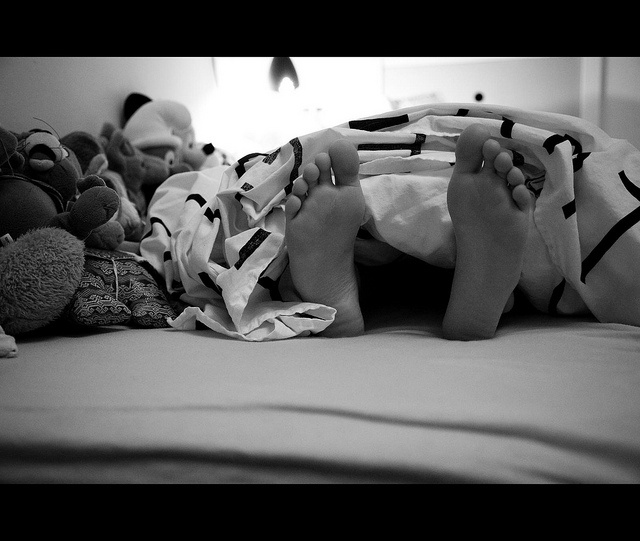Describe the objects in this image and their specific colors. I can see bed in black, darkgray, gray, and lightgray tones and people in black, gray, and lightgray tones in this image. 